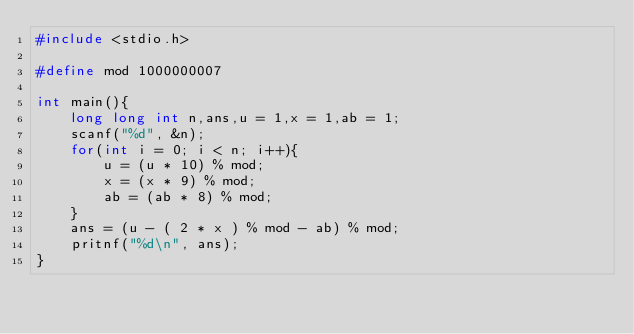<code> <loc_0><loc_0><loc_500><loc_500><_C_>#include <stdio.h>

#define mod 1000000007

int main(){
    long long int n,ans,u = 1,x = 1,ab = 1;
    scanf("%d", &n);
    for(int i = 0; i < n; i++){
        u = (u * 10) % mod;
        x = (x * 9) % mod;
        ab = (ab * 8) % mod;
    }
    ans = (u - ( 2 * x ) % mod - ab) % mod;
    pritnf("%d\n", ans);
}</code> 